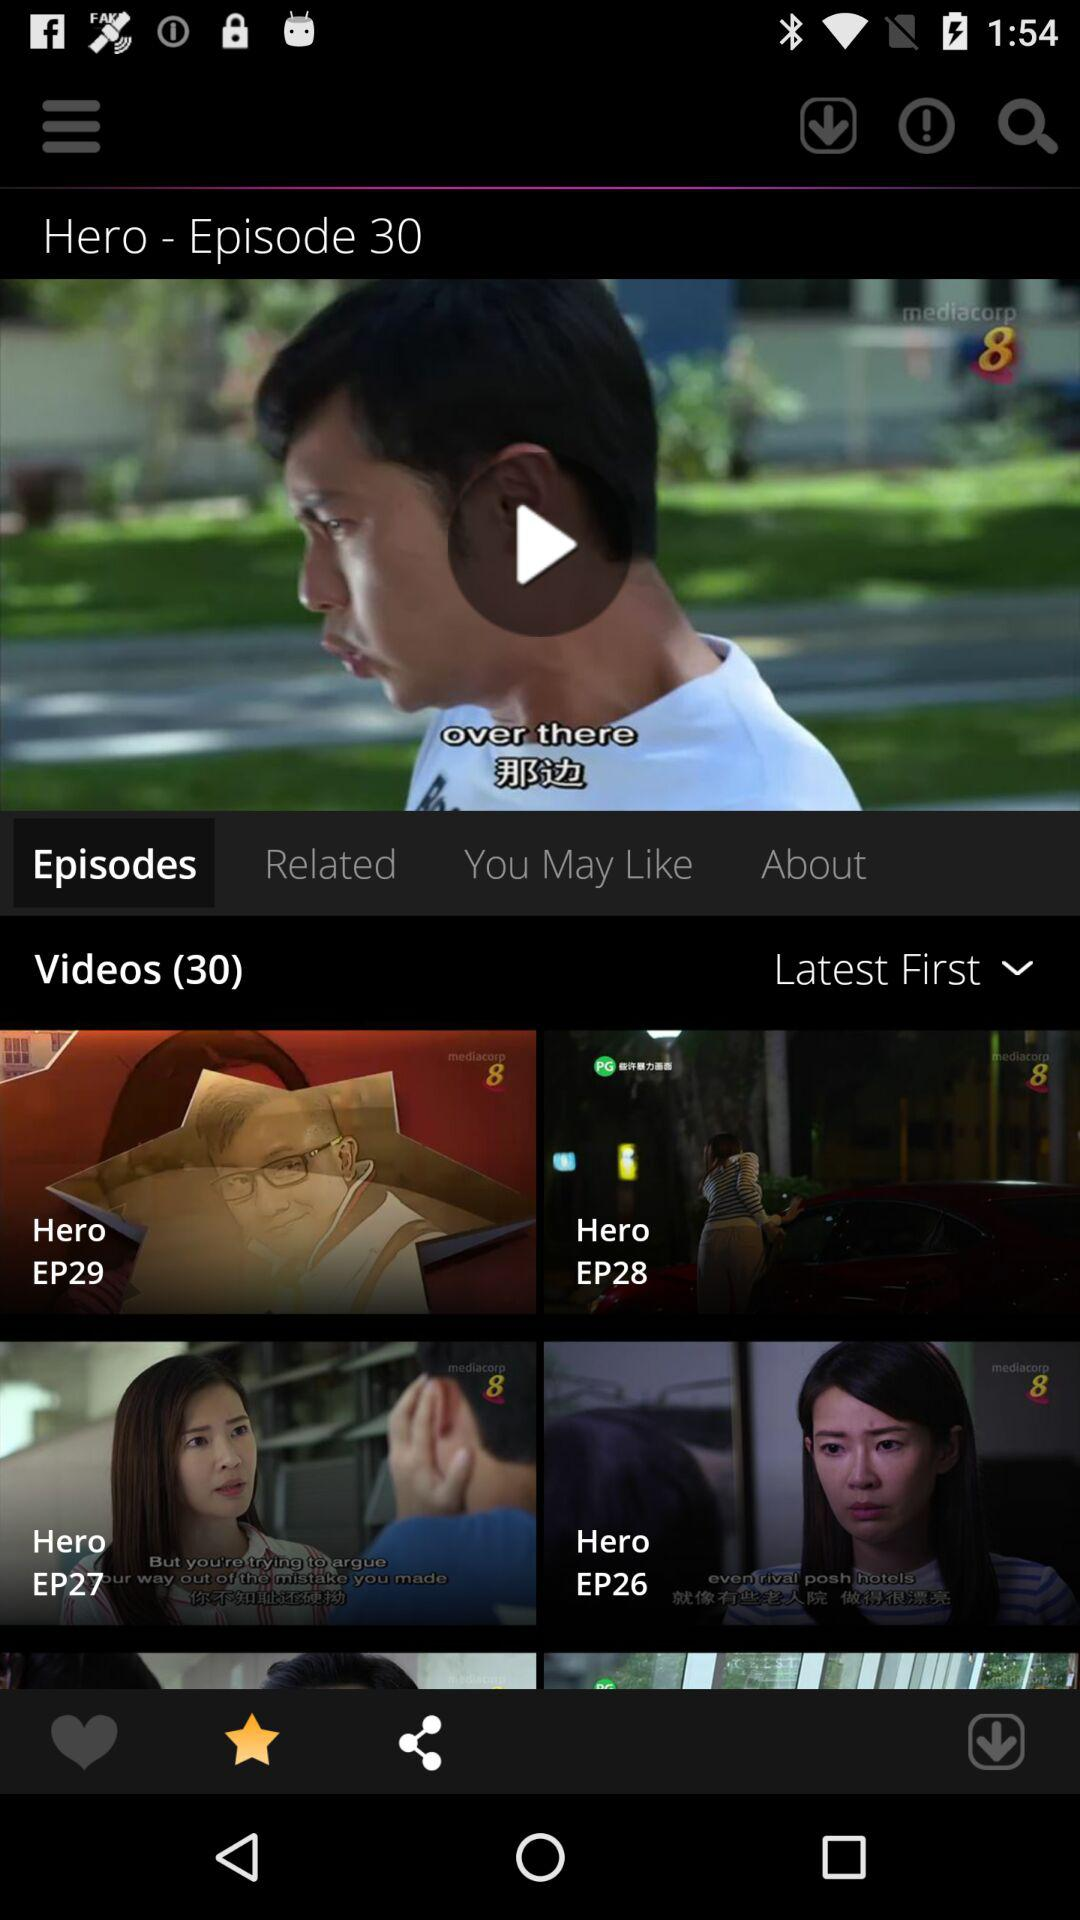What is the display order of the videos? The display order of the videos is "Latest First". 